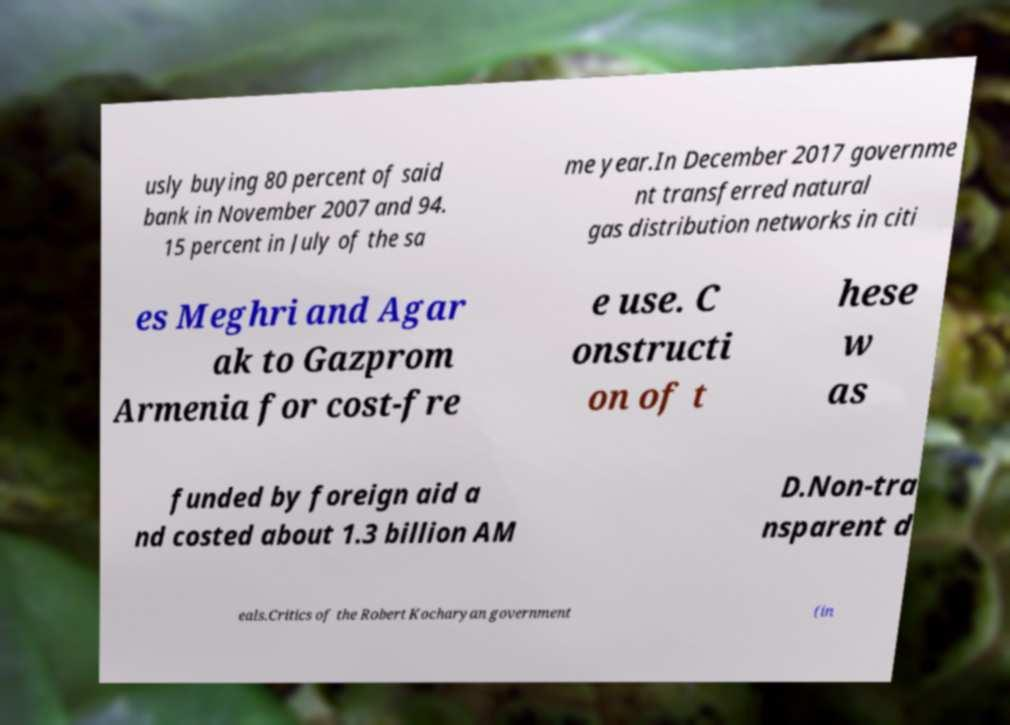What messages or text are displayed in this image? I need them in a readable, typed format. usly buying 80 percent of said bank in November 2007 and 94. 15 percent in July of the sa me year.In December 2017 governme nt transferred natural gas distribution networks in citi es Meghri and Agar ak to Gazprom Armenia for cost-fre e use. C onstructi on of t hese w as funded by foreign aid a nd costed about 1.3 billion AM D.Non-tra nsparent d eals.Critics of the Robert Kocharyan government (in 